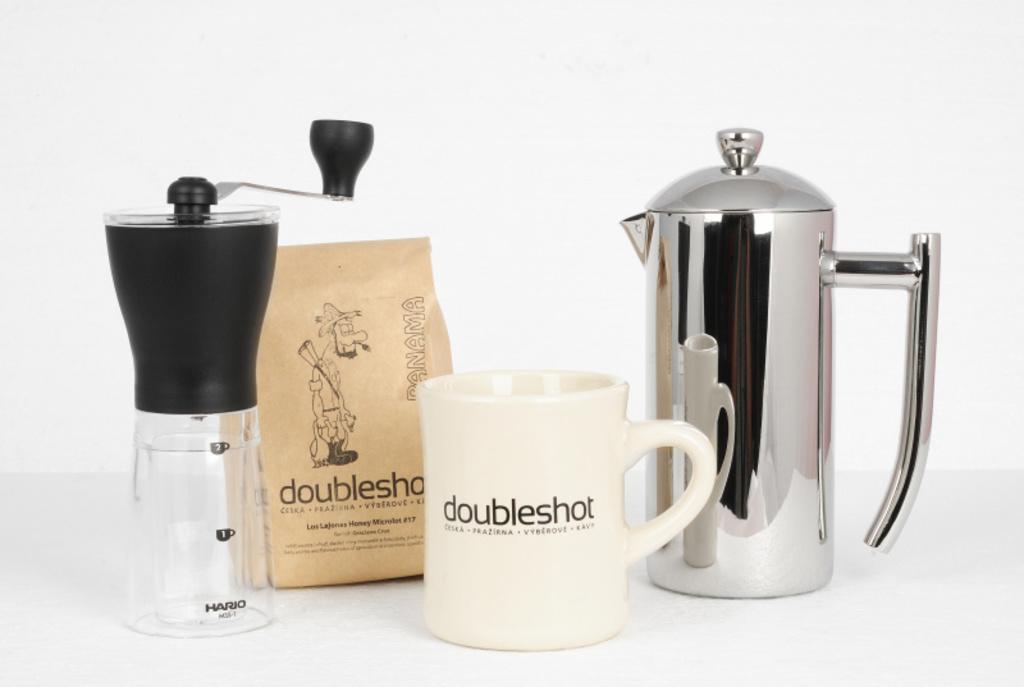What brand is on the brown box?
Provide a short and direct response. Doubleshot. What brand is the coffee grinder?
Make the answer very short. Doubleshot. 